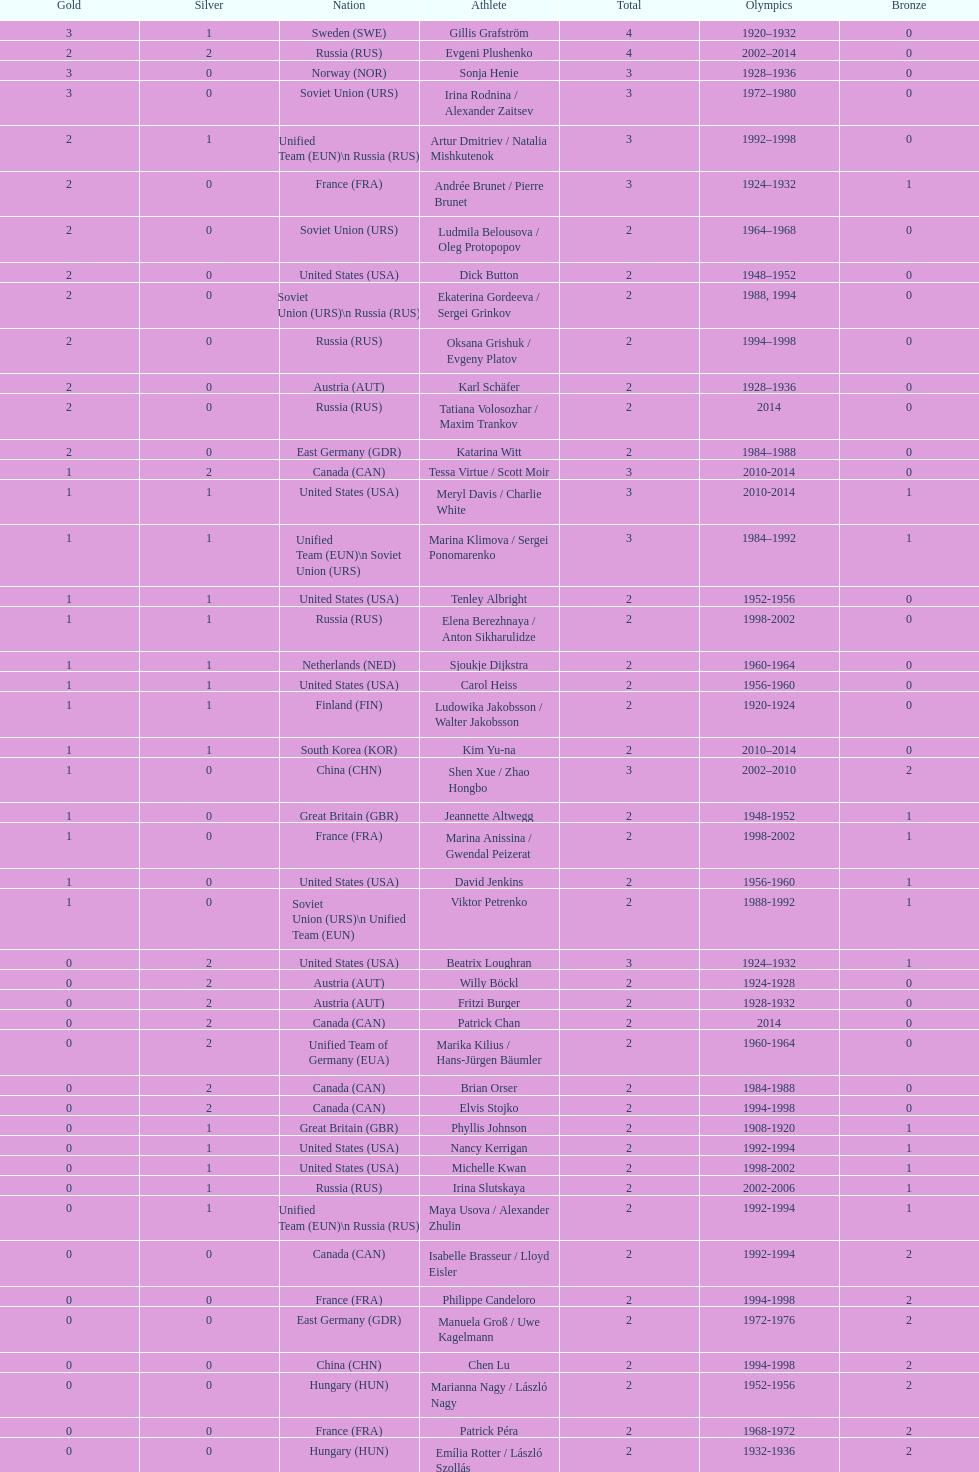How many total medals has the united states won in women's figure skating? 16. 